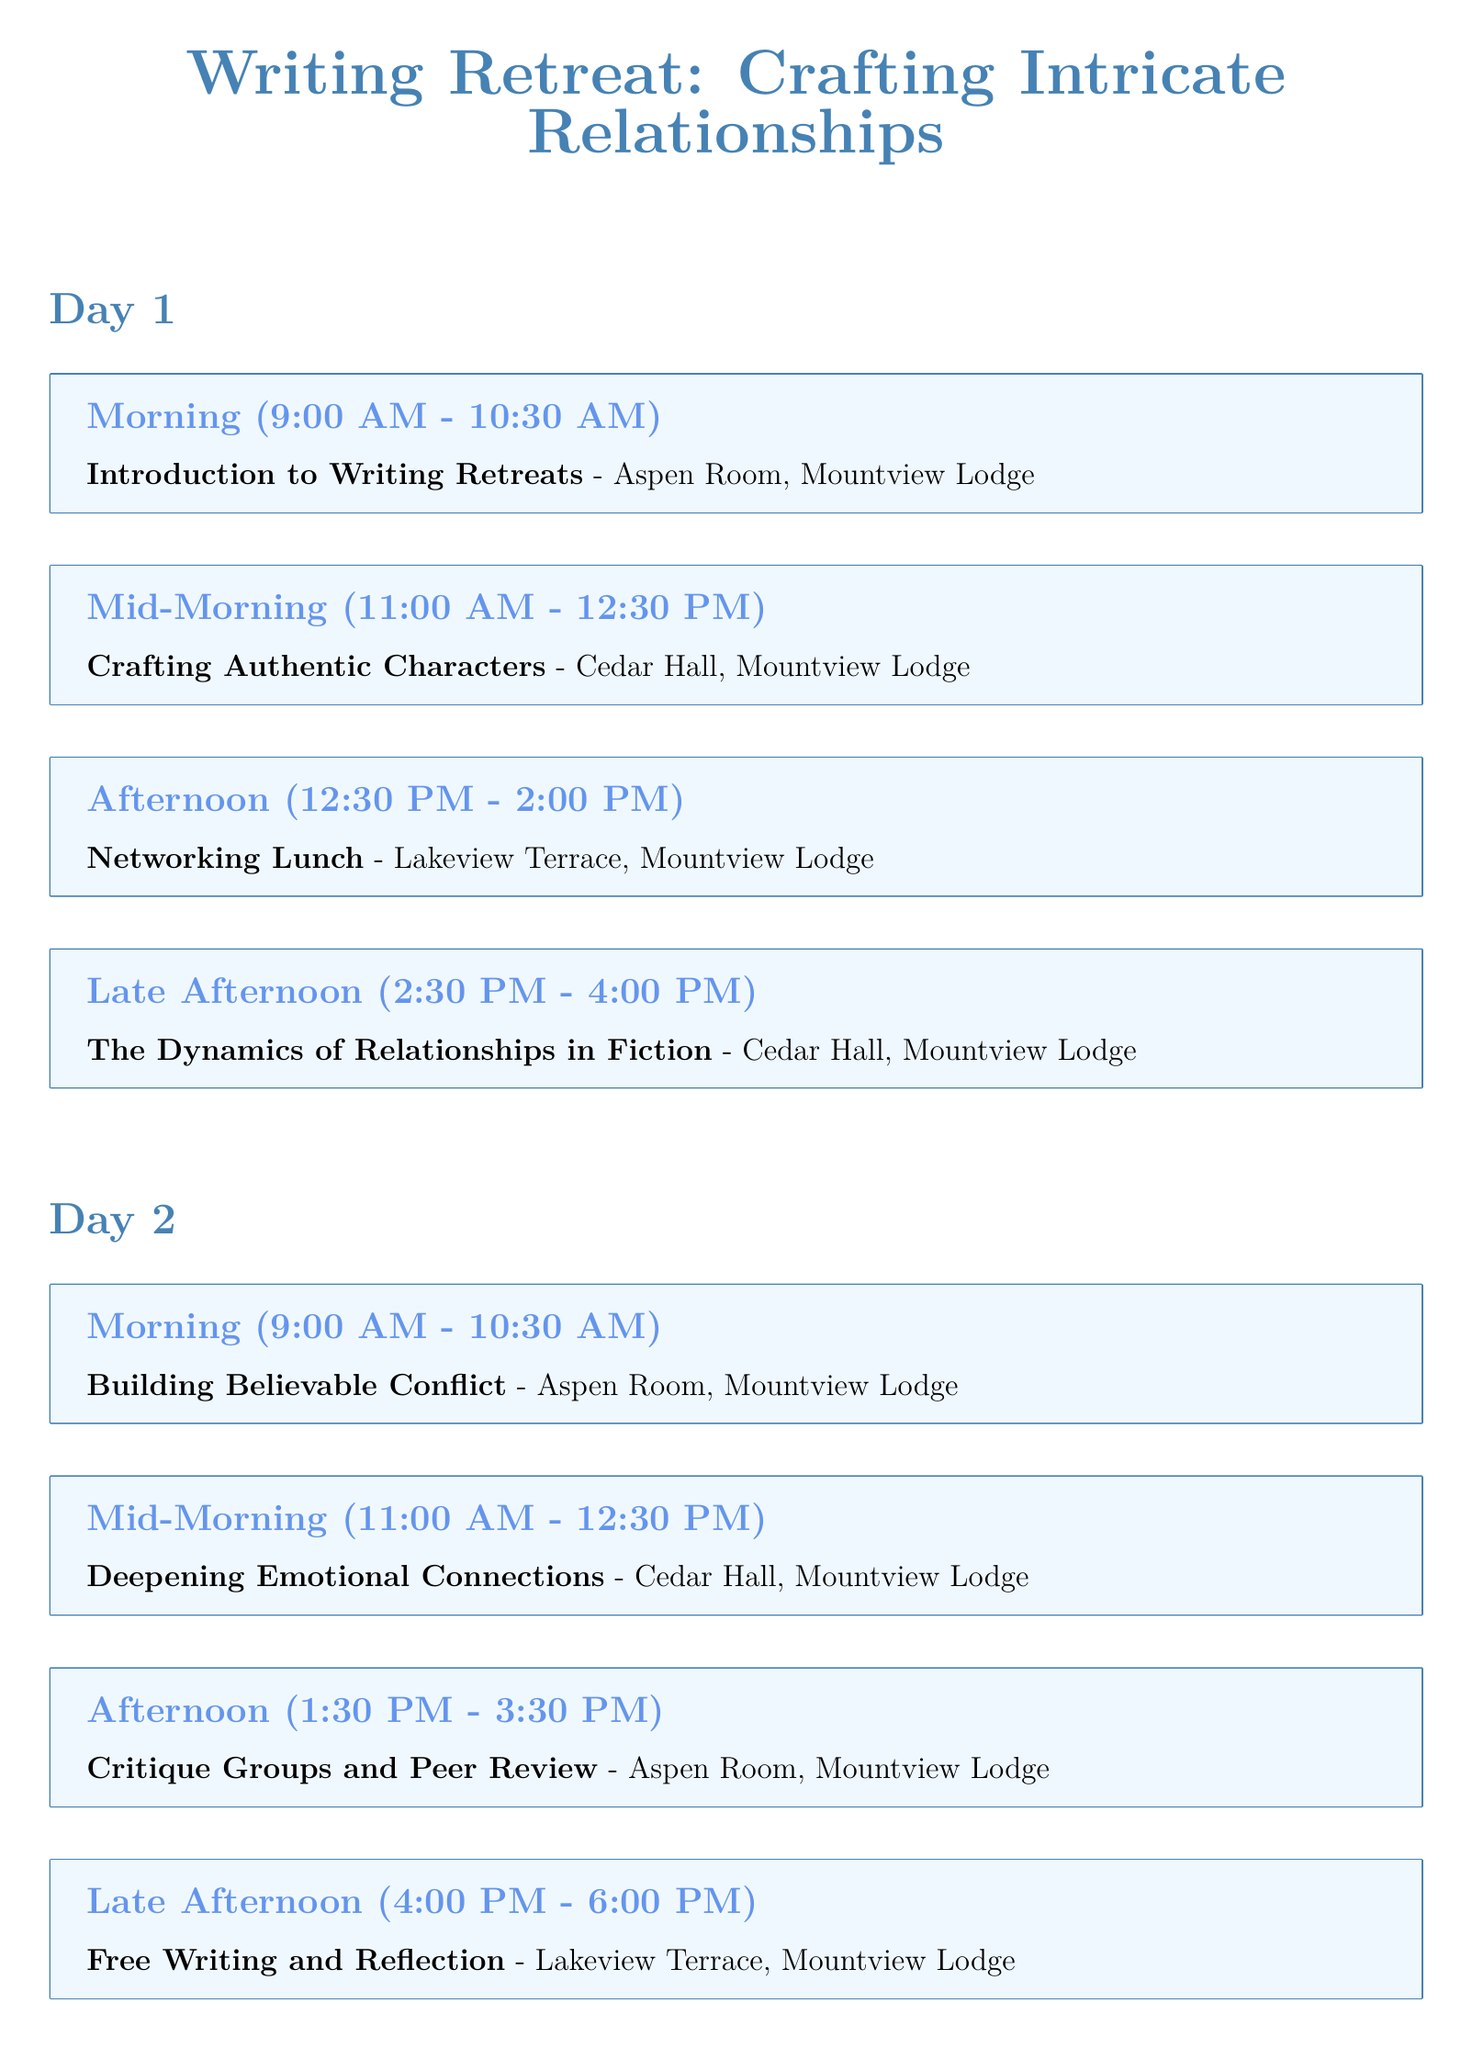What is the name of the writing retreat? The document states that the name of the retreat is "Crafting Intricate Relationships."
Answer: Crafting Intricate Relationships What room is the introduction held in? The introduction to writing retreats is held in the Aspen Room.
Answer: Aspen Room What time does the panel discussion start on Day 3? The panel discussion starts at 11:00 AM on Day 3.
Answer: 11:00 AM How long is the critique groups session? The critique groups session lasts for two hours, from 1:30 PM to 3:30 PM.
Answer: 2 hours What is the last event of the writing retreat? The last event listed in the document is the "Farewell Lunch and Certificate Ceremony."
Answer: Farewell Lunch and Certificate Ceremony Which day includes a session on "Deepening Emotional Connections"? The session titled "Deepening Emotional Connections" takes place on Day 2.
Answer: Day 2 What is the theme of the afternoon session on Day 1? The afternoon session on Day 1 focuses on "The Dynamics of Relationships in Fiction."
Answer: The Dynamics of Relationships in Fiction In which location is lunch served? Lunch is served at Lakeview Terrace, Mountview Lodge.
Answer: Lakeview Terrace What is the focus of the morning session on Day 3? The focus of the morning session on Day 3 is "Integrating Subplots with Character Relationships."
Answer: Integrating Subplots with Character Relationships 